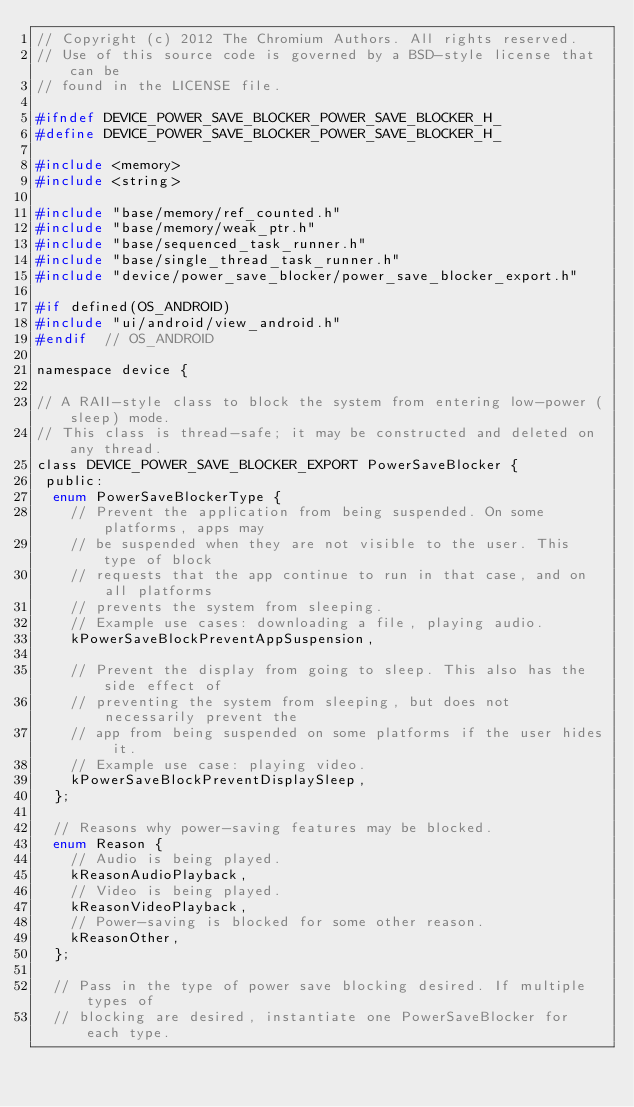<code> <loc_0><loc_0><loc_500><loc_500><_C_>// Copyright (c) 2012 The Chromium Authors. All rights reserved.
// Use of this source code is governed by a BSD-style license that can be
// found in the LICENSE file.

#ifndef DEVICE_POWER_SAVE_BLOCKER_POWER_SAVE_BLOCKER_H_
#define DEVICE_POWER_SAVE_BLOCKER_POWER_SAVE_BLOCKER_H_

#include <memory>
#include <string>

#include "base/memory/ref_counted.h"
#include "base/memory/weak_ptr.h"
#include "base/sequenced_task_runner.h"
#include "base/single_thread_task_runner.h"
#include "device/power_save_blocker/power_save_blocker_export.h"

#if defined(OS_ANDROID)
#include "ui/android/view_android.h"
#endif  // OS_ANDROID

namespace device {

// A RAII-style class to block the system from entering low-power (sleep) mode.
// This class is thread-safe; it may be constructed and deleted on any thread.
class DEVICE_POWER_SAVE_BLOCKER_EXPORT PowerSaveBlocker {
 public:
  enum PowerSaveBlockerType {
    // Prevent the application from being suspended. On some platforms, apps may
    // be suspended when they are not visible to the user. This type of block
    // requests that the app continue to run in that case, and on all platforms
    // prevents the system from sleeping.
    // Example use cases: downloading a file, playing audio.
    kPowerSaveBlockPreventAppSuspension,

    // Prevent the display from going to sleep. This also has the side effect of
    // preventing the system from sleeping, but does not necessarily prevent the
    // app from being suspended on some platforms if the user hides it.
    // Example use case: playing video.
    kPowerSaveBlockPreventDisplaySleep,
  };

  // Reasons why power-saving features may be blocked.
  enum Reason {
    // Audio is being played.
    kReasonAudioPlayback,
    // Video is being played.
    kReasonVideoPlayback,
    // Power-saving is blocked for some other reason.
    kReasonOther,
  };

  // Pass in the type of power save blocking desired. If multiple types of
  // blocking are desired, instantiate one PowerSaveBlocker for each type.</code> 